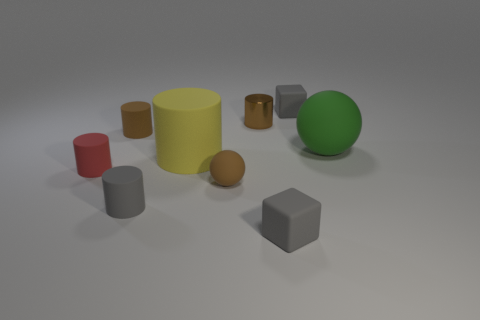Add 1 small blue rubber things. How many objects exist? 10 Subtract all small brown cylinders. How many cylinders are left? 3 Subtract all purple cubes. How many brown cylinders are left? 2 Subtract all cylinders. How many objects are left? 4 Subtract all gray cylinders. How many cylinders are left? 4 Add 2 large green matte objects. How many large green matte objects exist? 3 Subtract 0 red spheres. How many objects are left? 9 Subtract all red spheres. Subtract all gray cylinders. How many spheres are left? 2 Subtract all brown objects. Subtract all big yellow cylinders. How many objects are left? 5 Add 5 small brown metal cylinders. How many small brown metal cylinders are left? 6 